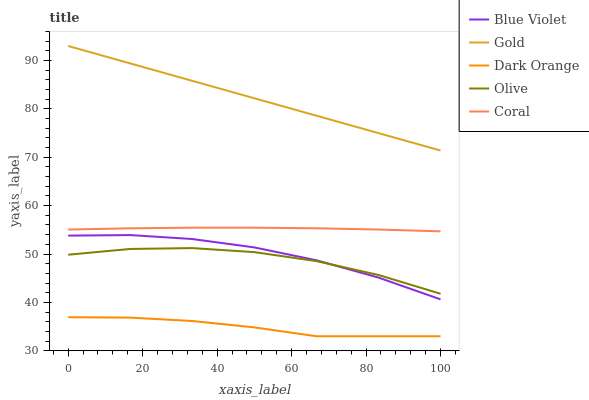Does Dark Orange have the minimum area under the curve?
Answer yes or no. Yes. Does Gold have the maximum area under the curve?
Answer yes or no. Yes. Does Coral have the minimum area under the curve?
Answer yes or no. No. Does Coral have the maximum area under the curve?
Answer yes or no. No. Is Gold the smoothest?
Answer yes or no. Yes. Is Olive the roughest?
Answer yes or no. Yes. Is Dark Orange the smoothest?
Answer yes or no. No. Is Dark Orange the roughest?
Answer yes or no. No. Does Dark Orange have the lowest value?
Answer yes or no. Yes. Does Coral have the lowest value?
Answer yes or no. No. Does Gold have the highest value?
Answer yes or no. Yes. Does Coral have the highest value?
Answer yes or no. No. Is Dark Orange less than Coral?
Answer yes or no. Yes. Is Olive greater than Dark Orange?
Answer yes or no. Yes. Does Blue Violet intersect Olive?
Answer yes or no. Yes. Is Blue Violet less than Olive?
Answer yes or no. No. Is Blue Violet greater than Olive?
Answer yes or no. No. Does Dark Orange intersect Coral?
Answer yes or no. No. 